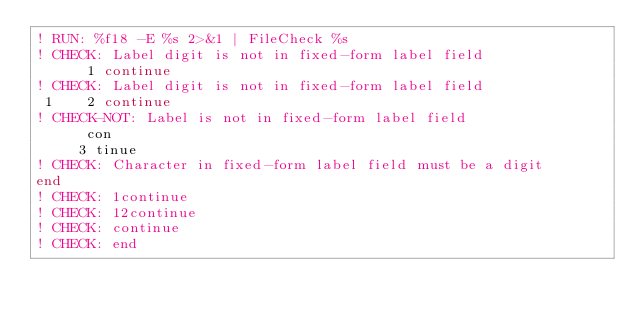<code> <loc_0><loc_0><loc_500><loc_500><_FORTRAN_>! RUN: %f18 -E %s 2>&1 | FileCheck %s
! CHECK: Label digit is not in fixed-form label field
      1 continue
! CHECK: Label digit is not in fixed-form label field
 1    2 continue
! CHECK-NOT: Label is not in fixed-form label field
      con
     3 tinue
! CHECK: Character in fixed-form label field must be a digit
end
! CHECK: 1continue
! CHECK: 12continue
! CHECK: continue
! CHECK: end
</code> 